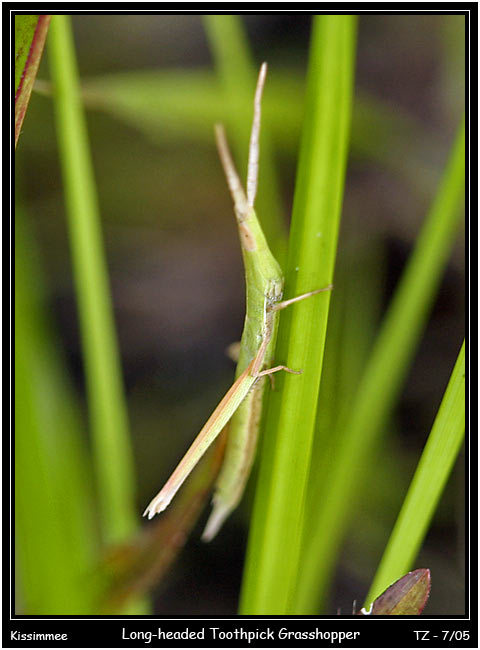Can you tell me more about the habitat where the Long-headed Toothpick Grasshopper lives? The Long-headed Toothpick Grasshopper dwells in ecosystems where tall grasses and green stems are abundant, such as meadows, grasslands, and the edges of forests. Its habitat choice is no coincidence; these environments offer it the necessary resources for survival, including food, mating opportunities, and, most importantly, the means to hide from predators within the greenery. This particular species thrives in spaces where its camouflage can be most effectively employed. 